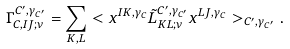Convert formula to latex. <formula><loc_0><loc_0><loc_500><loc_500>\Gamma ^ { C ^ { \prime } , \gamma _ { C ^ { \prime } } } _ { C , I J ; \nu } = \sum _ { K , L } < x ^ { I K , \gamma _ { C } } \tilde { L } _ { K L ; \nu } ^ { C ^ { \prime } , \gamma _ { C ^ { \prime } } } x ^ { L J , \gamma _ { C } } > _ { C ^ { \prime } , \gamma _ { C ^ { \prime } } } .</formula> 